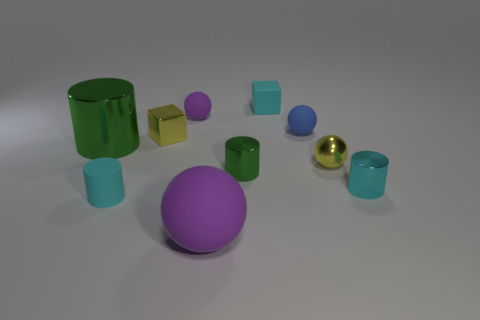What is the material of the tiny object that is the same color as the big matte thing?
Ensure brevity in your answer.  Rubber. There is a tiny ball that is behind the small blue matte ball; is its color the same as the big thing that is in front of the small cyan matte cylinder?
Your answer should be very brief. Yes. Is the yellow thing that is right of the tiny purple thing made of the same material as the tiny green cylinder?
Offer a very short reply. Yes. What is the color of the large object that is the same shape as the tiny blue thing?
Provide a short and direct response. Purple. How many other objects are the same color as the tiny shiny sphere?
Make the answer very short. 1. There is a yellow object that is in front of the big cylinder; is it the same shape as the purple object that is behind the large metallic object?
Your answer should be very brief. Yes. How many balls are either green metal things or metallic things?
Offer a terse response. 1. Is the number of yellow objects behind the big shiny cylinder less than the number of small purple metallic balls?
Ensure brevity in your answer.  No. What number of other things are there of the same material as the small blue thing
Provide a short and direct response. 4. What number of things are either purple things in front of the tiny blue matte thing or small objects?
Ensure brevity in your answer.  9. 